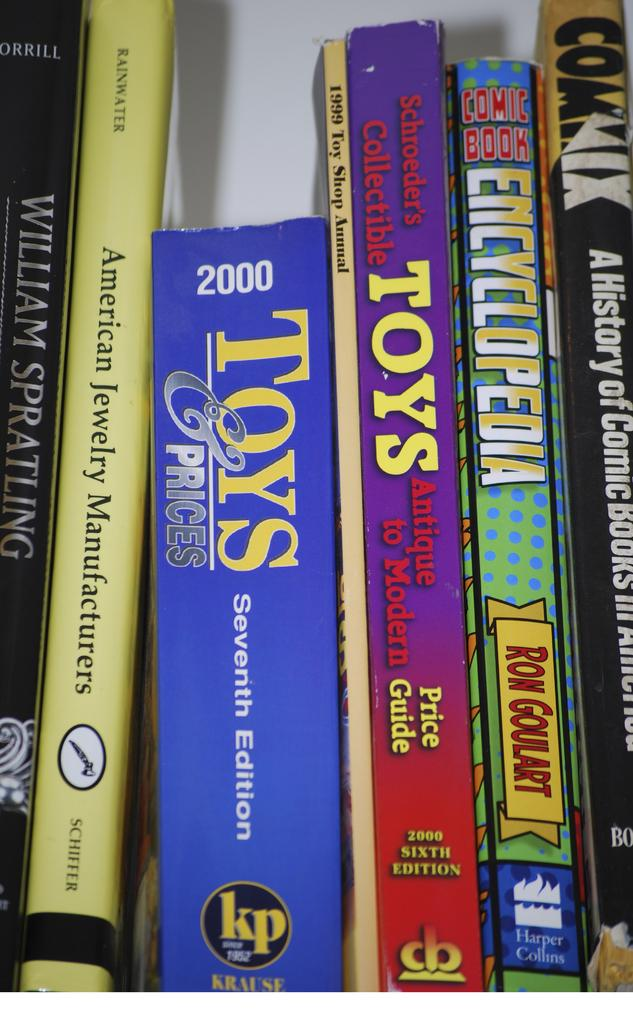<image>
Offer a succinct explanation of the picture presented. A bunch of books on the shelf one called Toys. 